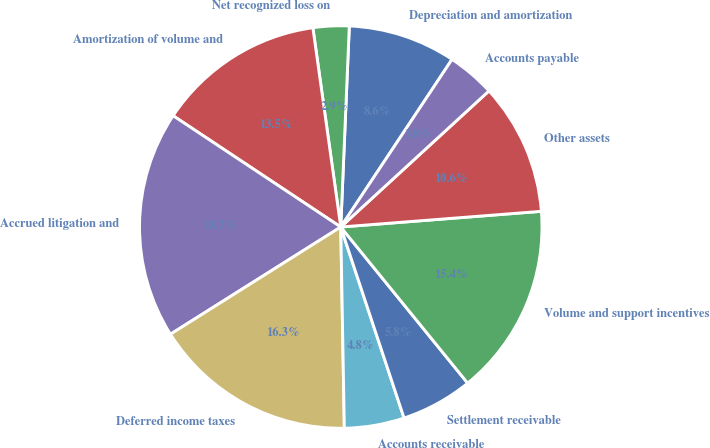Convert chart to OTSL. <chart><loc_0><loc_0><loc_500><loc_500><pie_chart><fcel>Depreciation and amortization<fcel>Net recognized loss on<fcel>Amortization of volume and<fcel>Accrued litigation and<fcel>Deferred income taxes<fcel>Accounts receivable<fcel>Settlement receivable<fcel>Volume and support incentives<fcel>Other assets<fcel>Accounts payable<nl><fcel>8.65%<fcel>2.89%<fcel>13.46%<fcel>18.27%<fcel>16.34%<fcel>4.81%<fcel>5.77%<fcel>15.38%<fcel>10.58%<fcel>3.85%<nl></chart> 